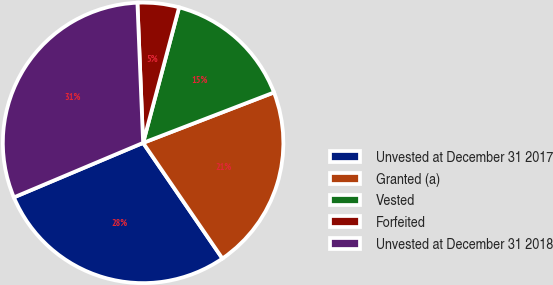<chart> <loc_0><loc_0><loc_500><loc_500><pie_chart><fcel>Unvested at December 31 2017<fcel>Granted (a)<fcel>Vested<fcel>Forfeited<fcel>Unvested at December 31 2018<nl><fcel>28.21%<fcel>21.28%<fcel>15.01%<fcel>4.78%<fcel>30.7%<nl></chart> 